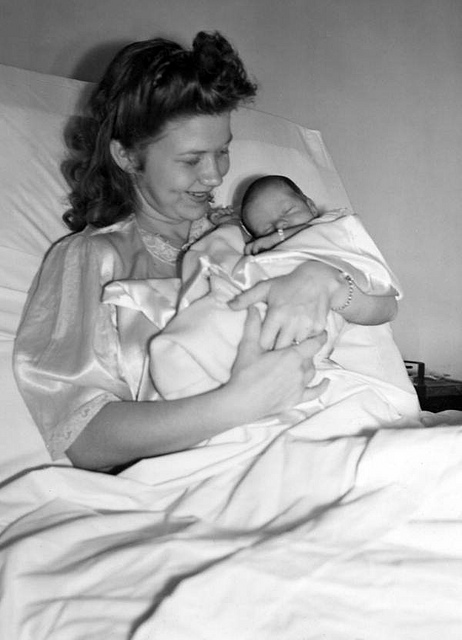<image>What year was the picture taken? It's unclear what year the picture was taken, it can be anywhere between the 1945 to 1975. What year was the picture taken? It is uncertain what year the picture was taken. It can be seen '1953', '1950', '1960', "50's", 'unknown', '1960', '1975', '1945', '1952' or '1950'. 